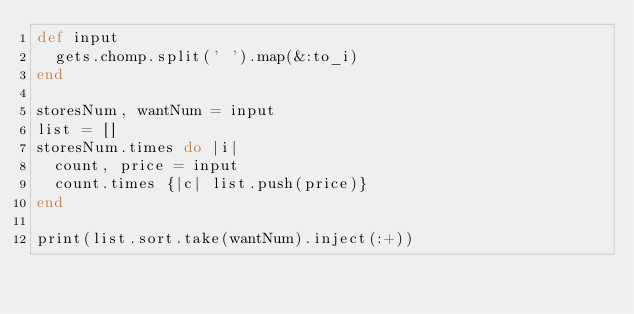<code> <loc_0><loc_0><loc_500><loc_500><_Ruby_>def input
  gets.chomp.split(' ').map(&:to_i)
end

storesNum, wantNum = input
list = []
storesNum.times do |i|
  count, price = input
  count.times {|c| list.push(price)}
end

print(list.sort.take(wantNum).inject(:+))</code> 